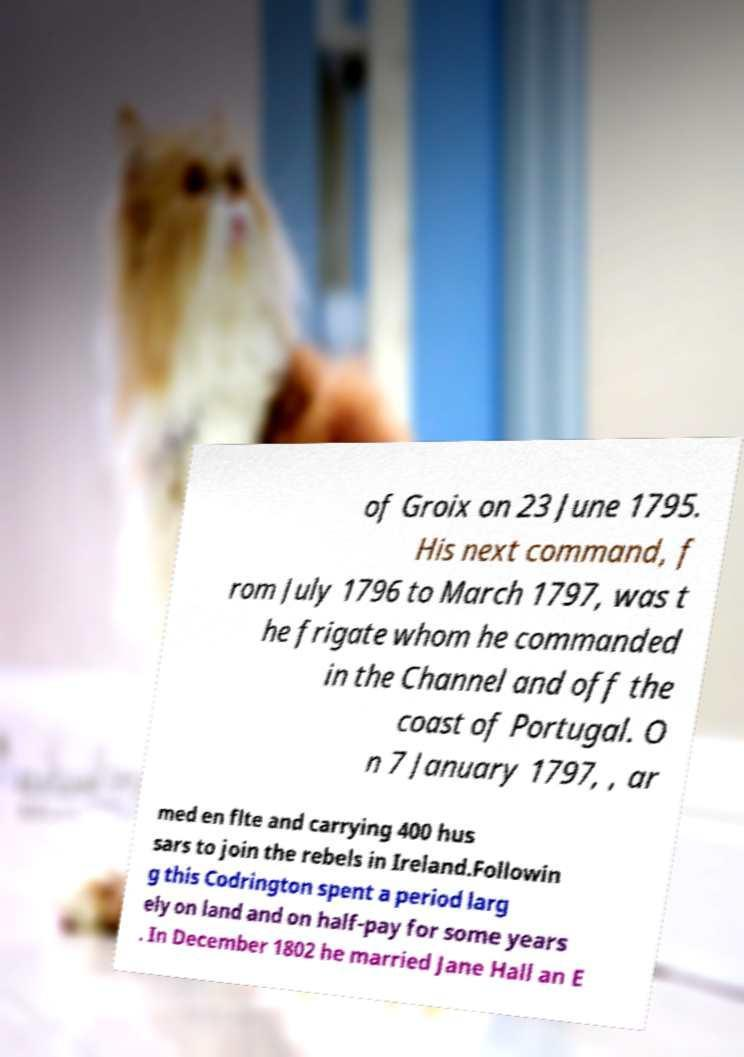Please read and relay the text visible in this image. What does it say? of Groix on 23 June 1795. His next command, f rom July 1796 to March 1797, was t he frigate whom he commanded in the Channel and off the coast of Portugal. O n 7 January 1797, , ar med en flte and carrying 400 hus sars to join the rebels in Ireland.Followin g this Codrington spent a period larg ely on land and on half-pay for some years . In December 1802 he married Jane Hall an E 